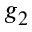<formula> <loc_0><loc_0><loc_500><loc_500>g _ { 2 }</formula> 